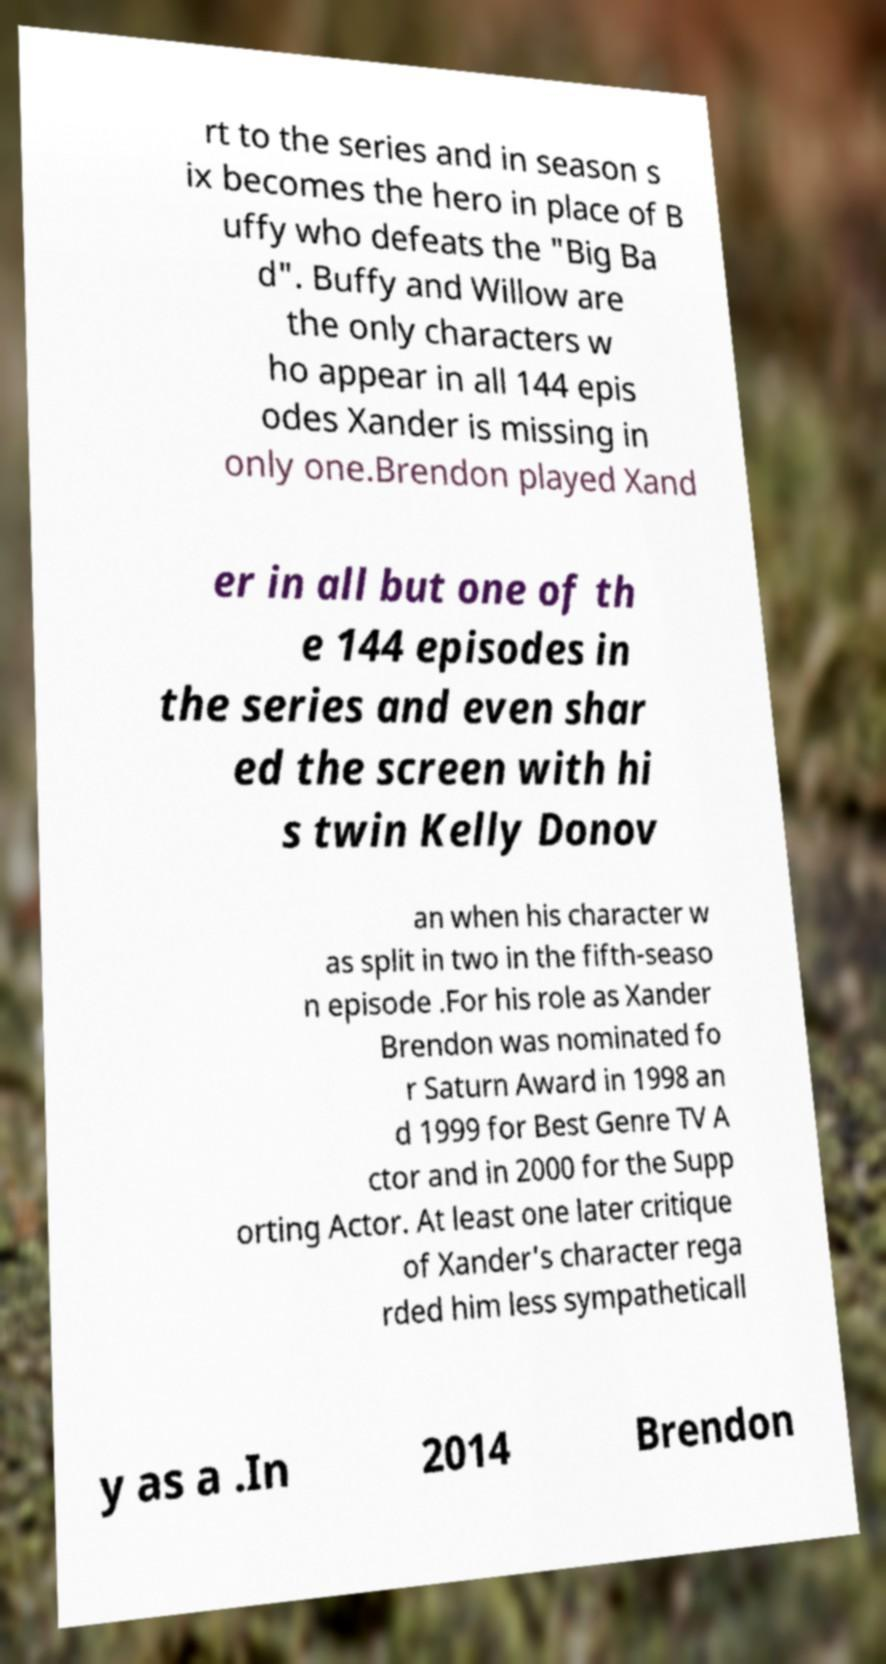Could you extract and type out the text from this image? rt to the series and in season s ix becomes the hero in place of B uffy who defeats the "Big Ba d". Buffy and Willow are the only characters w ho appear in all 144 epis odes Xander is missing in only one.Brendon played Xand er in all but one of th e 144 episodes in the series and even shar ed the screen with hi s twin Kelly Donov an when his character w as split in two in the fifth-seaso n episode .For his role as Xander Brendon was nominated fo r Saturn Award in 1998 an d 1999 for Best Genre TV A ctor and in 2000 for the Supp orting Actor. At least one later critique of Xander's character rega rded him less sympatheticall y as a .In 2014 Brendon 